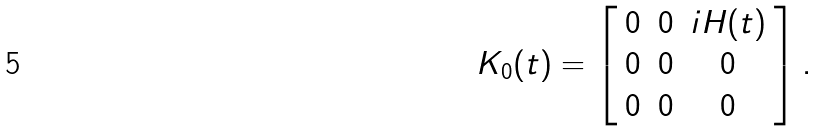<formula> <loc_0><loc_0><loc_500><loc_500>K _ { 0 } ( t ) = \left [ \begin{array} { c c c } 0 & 0 & i H ( t ) \\ 0 & 0 & 0 \\ 0 & 0 & 0 \\ \end{array} \right ] .</formula> 